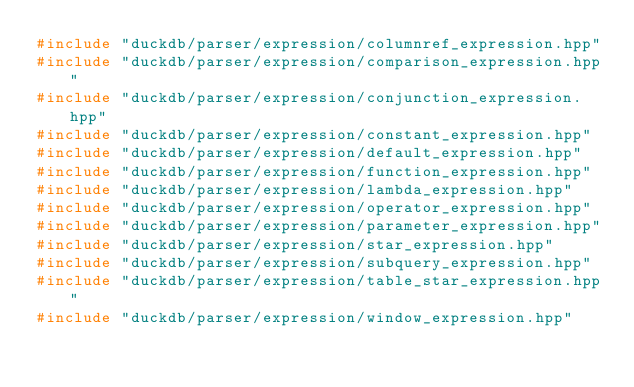Convert code to text. <code><loc_0><loc_0><loc_500><loc_500><_C++_>#include "duckdb/parser/expression/columnref_expression.hpp"
#include "duckdb/parser/expression/comparison_expression.hpp"
#include "duckdb/parser/expression/conjunction_expression.hpp"
#include "duckdb/parser/expression/constant_expression.hpp"
#include "duckdb/parser/expression/default_expression.hpp"
#include "duckdb/parser/expression/function_expression.hpp"
#include "duckdb/parser/expression/lambda_expression.hpp"
#include "duckdb/parser/expression/operator_expression.hpp"
#include "duckdb/parser/expression/parameter_expression.hpp"
#include "duckdb/parser/expression/star_expression.hpp"
#include "duckdb/parser/expression/subquery_expression.hpp"
#include "duckdb/parser/expression/table_star_expression.hpp"
#include "duckdb/parser/expression/window_expression.hpp"
</code> 